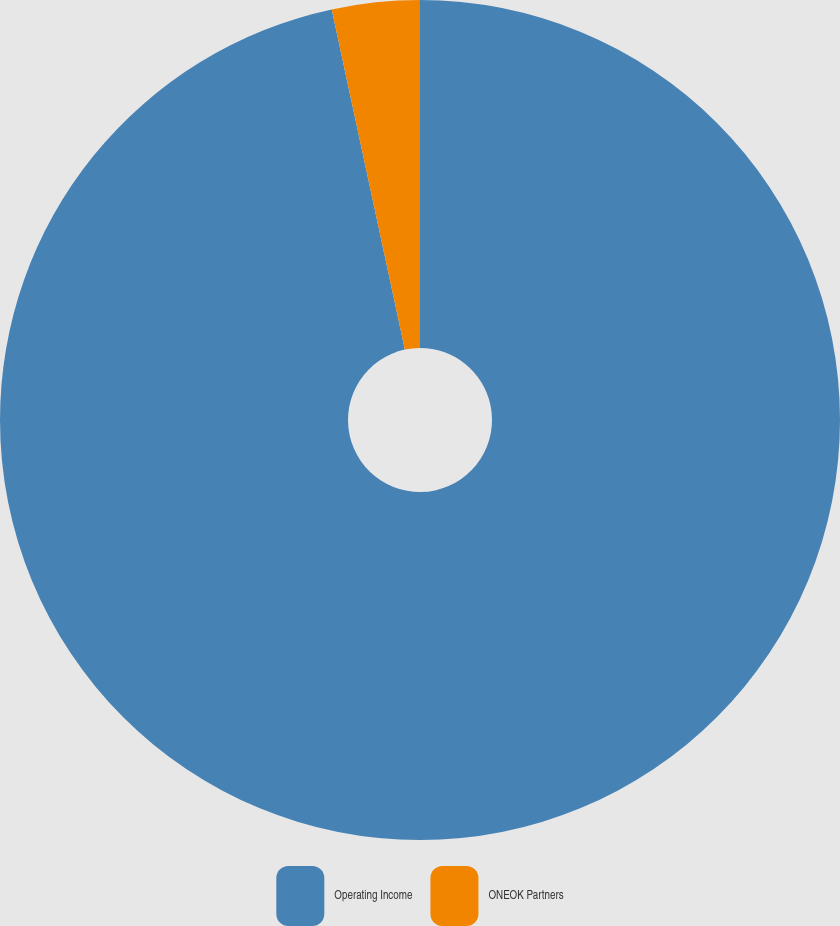<chart> <loc_0><loc_0><loc_500><loc_500><pie_chart><fcel>Operating Income<fcel>ONEOK Partners<nl><fcel>96.63%<fcel>3.37%<nl></chart> 